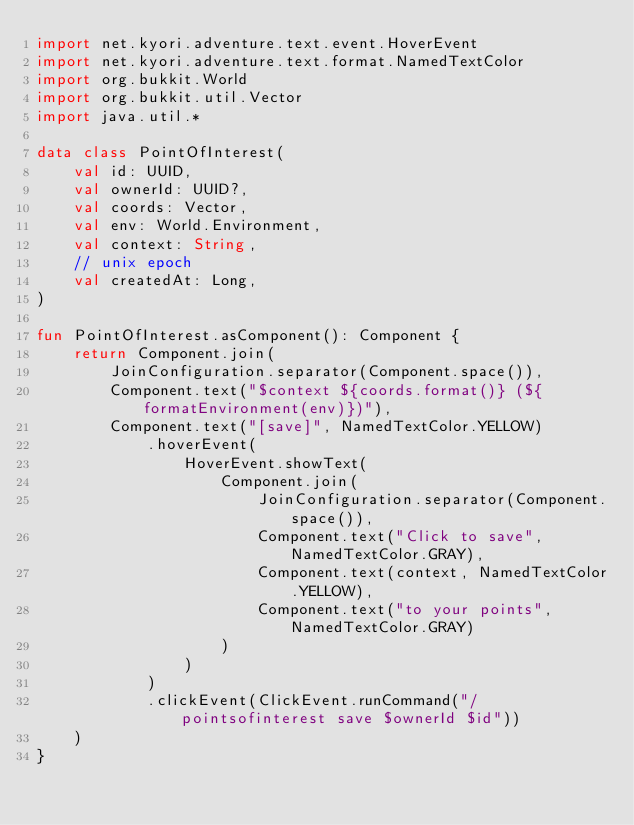Convert code to text. <code><loc_0><loc_0><loc_500><loc_500><_Kotlin_>import net.kyori.adventure.text.event.HoverEvent
import net.kyori.adventure.text.format.NamedTextColor
import org.bukkit.World
import org.bukkit.util.Vector
import java.util.*

data class PointOfInterest(
    val id: UUID,
    val ownerId: UUID?,
    val coords: Vector,
    val env: World.Environment,
    val context: String,
    // unix epoch
    val createdAt: Long,
)

fun PointOfInterest.asComponent(): Component {
    return Component.join(
        JoinConfiguration.separator(Component.space()),
        Component.text("$context ${coords.format()} (${formatEnvironment(env)})"),
        Component.text("[save]", NamedTextColor.YELLOW)
            .hoverEvent(
                HoverEvent.showText(
                    Component.join(
                        JoinConfiguration.separator(Component.space()),
                        Component.text("Click to save", NamedTextColor.GRAY),
                        Component.text(context, NamedTextColor.YELLOW),
                        Component.text("to your points", NamedTextColor.GRAY)
                    )
                )
            )
            .clickEvent(ClickEvent.runCommand("/pointsofinterest save $ownerId $id"))
    )
}
</code> 